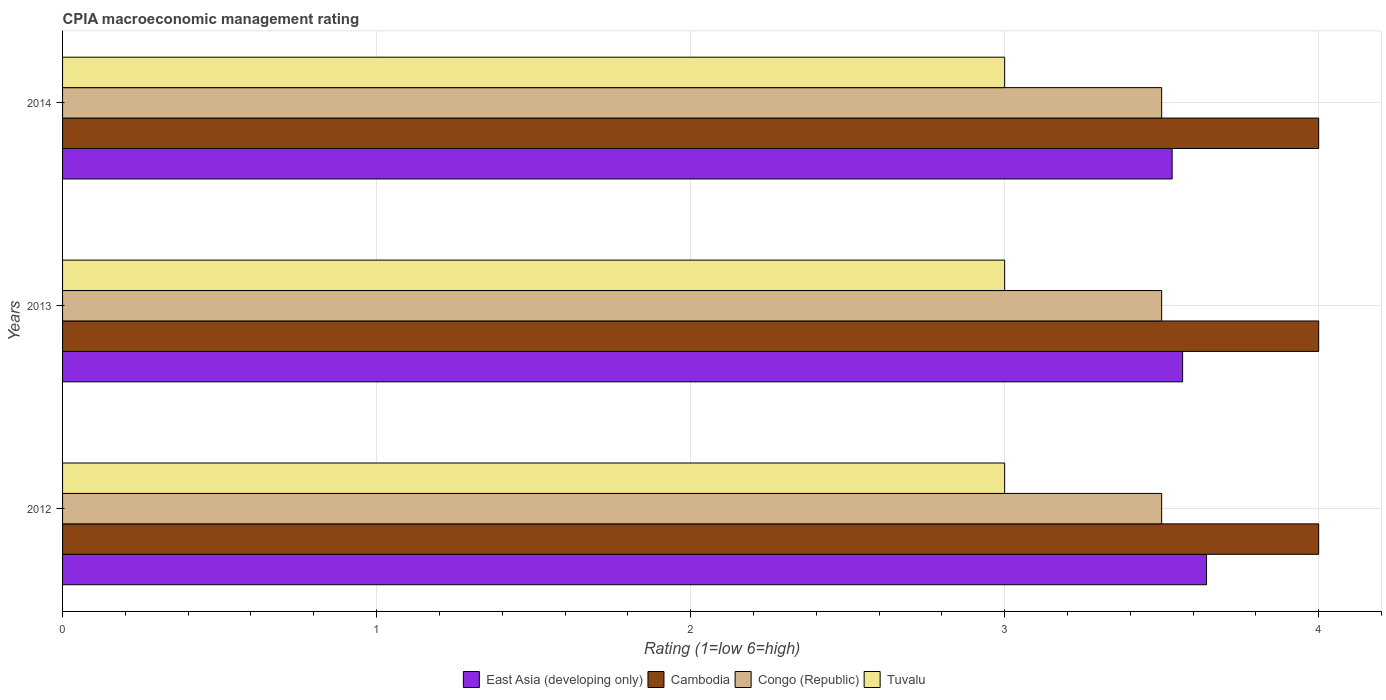How many groups of bars are there?
Your answer should be compact. 3. Are the number of bars per tick equal to the number of legend labels?
Make the answer very short. Yes. Are the number of bars on each tick of the Y-axis equal?
Offer a terse response. Yes. Across all years, what is the maximum CPIA rating in Tuvalu?
Provide a succinct answer. 3. In which year was the CPIA rating in Congo (Republic) maximum?
Your answer should be very brief. 2012. In which year was the CPIA rating in Tuvalu minimum?
Keep it short and to the point. 2012. What is the total CPIA rating in East Asia (developing only) in the graph?
Your answer should be compact. 10.74. What is the difference between the CPIA rating in Cambodia in 2014 and the CPIA rating in East Asia (developing only) in 2012?
Offer a terse response. 0.36. In the year 2012, what is the difference between the CPIA rating in Tuvalu and CPIA rating in Cambodia?
Offer a very short reply. -1. What is the ratio of the CPIA rating in Congo (Republic) in 2012 to that in 2014?
Offer a terse response. 1. Is the difference between the CPIA rating in Tuvalu in 2013 and 2014 greater than the difference between the CPIA rating in Cambodia in 2013 and 2014?
Your answer should be compact. No. What does the 2nd bar from the top in 2013 represents?
Keep it short and to the point. Congo (Republic). What does the 4th bar from the bottom in 2014 represents?
Ensure brevity in your answer.  Tuvalu. Is it the case that in every year, the sum of the CPIA rating in Cambodia and CPIA rating in East Asia (developing only) is greater than the CPIA rating in Congo (Republic)?
Offer a very short reply. Yes. Are all the bars in the graph horizontal?
Ensure brevity in your answer.  Yes. Are the values on the major ticks of X-axis written in scientific E-notation?
Your response must be concise. No. Does the graph contain any zero values?
Ensure brevity in your answer.  No. How many legend labels are there?
Your answer should be compact. 4. How are the legend labels stacked?
Your response must be concise. Horizontal. What is the title of the graph?
Provide a short and direct response. CPIA macroeconomic management rating. Does "Austria" appear as one of the legend labels in the graph?
Your answer should be compact. No. What is the label or title of the Y-axis?
Your answer should be very brief. Years. What is the Rating (1=low 6=high) in East Asia (developing only) in 2012?
Make the answer very short. 3.64. What is the Rating (1=low 6=high) of Cambodia in 2012?
Give a very brief answer. 4. What is the Rating (1=low 6=high) of Congo (Republic) in 2012?
Your answer should be very brief. 3.5. What is the Rating (1=low 6=high) in East Asia (developing only) in 2013?
Offer a very short reply. 3.57. What is the Rating (1=low 6=high) in Tuvalu in 2013?
Provide a short and direct response. 3. What is the Rating (1=low 6=high) in East Asia (developing only) in 2014?
Give a very brief answer. 3.53. What is the Rating (1=low 6=high) in Cambodia in 2014?
Your response must be concise. 4. Across all years, what is the maximum Rating (1=low 6=high) in East Asia (developing only)?
Your response must be concise. 3.64. Across all years, what is the maximum Rating (1=low 6=high) of Congo (Republic)?
Keep it short and to the point. 3.5. Across all years, what is the minimum Rating (1=low 6=high) in East Asia (developing only)?
Keep it short and to the point. 3.53. Across all years, what is the minimum Rating (1=low 6=high) of Cambodia?
Keep it short and to the point. 4. Across all years, what is the minimum Rating (1=low 6=high) in Congo (Republic)?
Your response must be concise. 3.5. Across all years, what is the minimum Rating (1=low 6=high) of Tuvalu?
Make the answer very short. 3. What is the total Rating (1=low 6=high) in East Asia (developing only) in the graph?
Your answer should be compact. 10.74. What is the difference between the Rating (1=low 6=high) in East Asia (developing only) in 2012 and that in 2013?
Your answer should be very brief. 0.08. What is the difference between the Rating (1=low 6=high) of Tuvalu in 2012 and that in 2013?
Provide a short and direct response. 0. What is the difference between the Rating (1=low 6=high) in East Asia (developing only) in 2012 and that in 2014?
Your answer should be compact. 0.11. What is the difference between the Rating (1=low 6=high) of Cambodia in 2012 and that in 2014?
Keep it short and to the point. 0. What is the difference between the Rating (1=low 6=high) in Cambodia in 2013 and that in 2014?
Offer a terse response. 0. What is the difference between the Rating (1=low 6=high) in Congo (Republic) in 2013 and that in 2014?
Provide a short and direct response. 0. What is the difference between the Rating (1=low 6=high) of Tuvalu in 2013 and that in 2014?
Provide a succinct answer. 0. What is the difference between the Rating (1=low 6=high) in East Asia (developing only) in 2012 and the Rating (1=low 6=high) in Cambodia in 2013?
Your answer should be compact. -0.36. What is the difference between the Rating (1=low 6=high) in East Asia (developing only) in 2012 and the Rating (1=low 6=high) in Congo (Republic) in 2013?
Your answer should be very brief. 0.14. What is the difference between the Rating (1=low 6=high) of East Asia (developing only) in 2012 and the Rating (1=low 6=high) of Tuvalu in 2013?
Provide a succinct answer. 0.64. What is the difference between the Rating (1=low 6=high) of Congo (Republic) in 2012 and the Rating (1=low 6=high) of Tuvalu in 2013?
Ensure brevity in your answer.  0.5. What is the difference between the Rating (1=low 6=high) of East Asia (developing only) in 2012 and the Rating (1=low 6=high) of Cambodia in 2014?
Offer a very short reply. -0.36. What is the difference between the Rating (1=low 6=high) of East Asia (developing only) in 2012 and the Rating (1=low 6=high) of Congo (Republic) in 2014?
Your answer should be very brief. 0.14. What is the difference between the Rating (1=low 6=high) of East Asia (developing only) in 2012 and the Rating (1=low 6=high) of Tuvalu in 2014?
Give a very brief answer. 0.64. What is the difference between the Rating (1=low 6=high) in Cambodia in 2012 and the Rating (1=low 6=high) in Congo (Republic) in 2014?
Offer a terse response. 0.5. What is the difference between the Rating (1=low 6=high) in Cambodia in 2012 and the Rating (1=low 6=high) in Tuvalu in 2014?
Give a very brief answer. 1. What is the difference between the Rating (1=low 6=high) in East Asia (developing only) in 2013 and the Rating (1=low 6=high) in Cambodia in 2014?
Keep it short and to the point. -0.43. What is the difference between the Rating (1=low 6=high) in East Asia (developing only) in 2013 and the Rating (1=low 6=high) in Congo (Republic) in 2014?
Keep it short and to the point. 0.07. What is the difference between the Rating (1=low 6=high) in East Asia (developing only) in 2013 and the Rating (1=low 6=high) in Tuvalu in 2014?
Provide a short and direct response. 0.57. What is the difference between the Rating (1=low 6=high) of Congo (Republic) in 2013 and the Rating (1=low 6=high) of Tuvalu in 2014?
Keep it short and to the point. 0.5. What is the average Rating (1=low 6=high) in East Asia (developing only) per year?
Offer a very short reply. 3.58. What is the average Rating (1=low 6=high) in Cambodia per year?
Your answer should be compact. 4. What is the average Rating (1=low 6=high) of Congo (Republic) per year?
Offer a terse response. 3.5. What is the average Rating (1=low 6=high) in Tuvalu per year?
Provide a short and direct response. 3. In the year 2012, what is the difference between the Rating (1=low 6=high) in East Asia (developing only) and Rating (1=low 6=high) in Cambodia?
Offer a very short reply. -0.36. In the year 2012, what is the difference between the Rating (1=low 6=high) of East Asia (developing only) and Rating (1=low 6=high) of Congo (Republic)?
Ensure brevity in your answer.  0.14. In the year 2012, what is the difference between the Rating (1=low 6=high) in East Asia (developing only) and Rating (1=low 6=high) in Tuvalu?
Make the answer very short. 0.64. In the year 2012, what is the difference between the Rating (1=low 6=high) of Cambodia and Rating (1=low 6=high) of Congo (Republic)?
Provide a succinct answer. 0.5. In the year 2013, what is the difference between the Rating (1=low 6=high) of East Asia (developing only) and Rating (1=low 6=high) of Cambodia?
Provide a succinct answer. -0.43. In the year 2013, what is the difference between the Rating (1=low 6=high) in East Asia (developing only) and Rating (1=low 6=high) in Congo (Republic)?
Provide a short and direct response. 0.07. In the year 2013, what is the difference between the Rating (1=low 6=high) of East Asia (developing only) and Rating (1=low 6=high) of Tuvalu?
Provide a short and direct response. 0.57. In the year 2013, what is the difference between the Rating (1=low 6=high) of Cambodia and Rating (1=low 6=high) of Congo (Republic)?
Provide a succinct answer. 0.5. In the year 2013, what is the difference between the Rating (1=low 6=high) in Cambodia and Rating (1=low 6=high) in Tuvalu?
Provide a succinct answer. 1. In the year 2013, what is the difference between the Rating (1=low 6=high) in Congo (Republic) and Rating (1=low 6=high) in Tuvalu?
Provide a succinct answer. 0.5. In the year 2014, what is the difference between the Rating (1=low 6=high) in East Asia (developing only) and Rating (1=low 6=high) in Cambodia?
Make the answer very short. -0.47. In the year 2014, what is the difference between the Rating (1=low 6=high) in East Asia (developing only) and Rating (1=low 6=high) in Congo (Republic)?
Make the answer very short. 0.03. In the year 2014, what is the difference between the Rating (1=low 6=high) of East Asia (developing only) and Rating (1=low 6=high) of Tuvalu?
Provide a short and direct response. 0.53. In the year 2014, what is the difference between the Rating (1=low 6=high) of Cambodia and Rating (1=low 6=high) of Tuvalu?
Offer a very short reply. 1. What is the ratio of the Rating (1=low 6=high) in East Asia (developing only) in 2012 to that in 2013?
Keep it short and to the point. 1.02. What is the ratio of the Rating (1=low 6=high) of Cambodia in 2012 to that in 2013?
Make the answer very short. 1. What is the ratio of the Rating (1=low 6=high) of Congo (Republic) in 2012 to that in 2013?
Offer a very short reply. 1. What is the ratio of the Rating (1=low 6=high) of Tuvalu in 2012 to that in 2013?
Give a very brief answer. 1. What is the ratio of the Rating (1=low 6=high) in East Asia (developing only) in 2012 to that in 2014?
Your response must be concise. 1.03. What is the ratio of the Rating (1=low 6=high) in Cambodia in 2012 to that in 2014?
Offer a terse response. 1. What is the ratio of the Rating (1=low 6=high) of Tuvalu in 2012 to that in 2014?
Give a very brief answer. 1. What is the ratio of the Rating (1=low 6=high) in East Asia (developing only) in 2013 to that in 2014?
Provide a short and direct response. 1.01. What is the ratio of the Rating (1=low 6=high) in Cambodia in 2013 to that in 2014?
Ensure brevity in your answer.  1. What is the ratio of the Rating (1=low 6=high) in Tuvalu in 2013 to that in 2014?
Your response must be concise. 1. What is the difference between the highest and the second highest Rating (1=low 6=high) in East Asia (developing only)?
Provide a short and direct response. 0.08. What is the difference between the highest and the second highest Rating (1=low 6=high) of Tuvalu?
Your response must be concise. 0. What is the difference between the highest and the lowest Rating (1=low 6=high) in East Asia (developing only)?
Provide a succinct answer. 0.11. What is the difference between the highest and the lowest Rating (1=low 6=high) in Cambodia?
Your answer should be very brief. 0. What is the difference between the highest and the lowest Rating (1=low 6=high) in Congo (Republic)?
Provide a succinct answer. 0. What is the difference between the highest and the lowest Rating (1=low 6=high) of Tuvalu?
Ensure brevity in your answer.  0. 